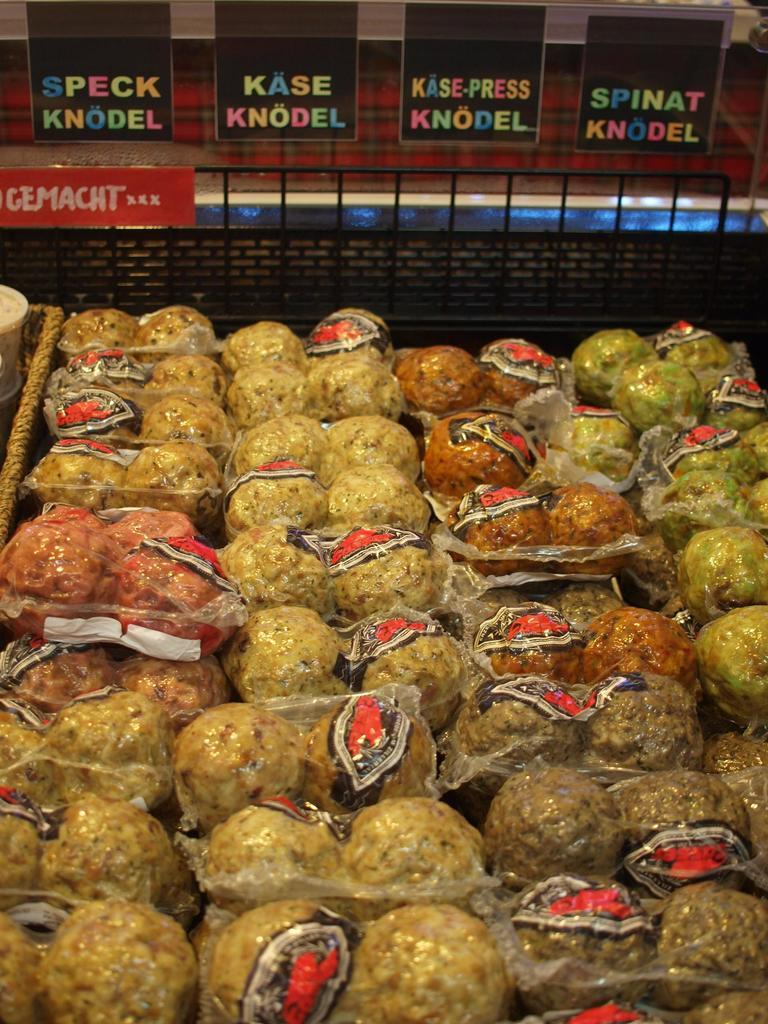What type of items are packed in the packets in the image? The food items are packed in packets in the image. What can be seen behind the food items? There is a black stand behind the food items. What else is present in the image besides the food items and the black stand? There are posters with text on them in the image. Can you tell me how many pets are visible in the image? There are no pets present in the image. What type of industry is being represented in the image? The image does not depict any specific industry; it shows food items packed in packets, a black stand, and posters with text. 